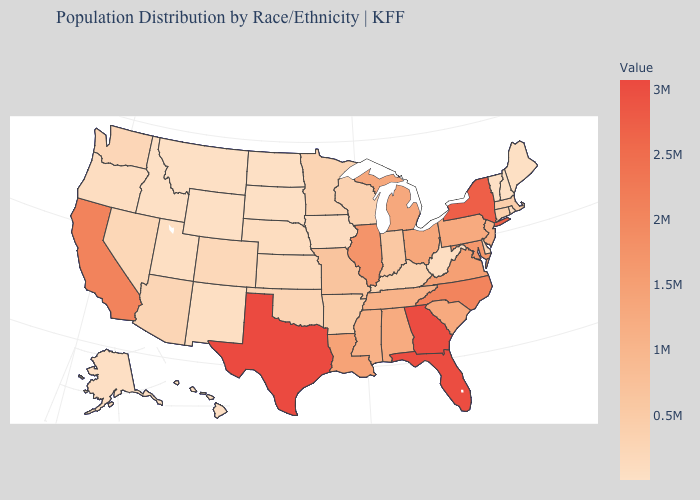Which states have the lowest value in the South?
Quick response, please. West Virginia. Among the states that border California , which have the highest value?
Give a very brief answer. Arizona. Which states have the lowest value in the Northeast?
Write a very short answer. Vermont. Which states have the highest value in the USA?
Concise answer only. Texas. Among the states that border Minnesota , which have the highest value?
Answer briefly. Wisconsin. 